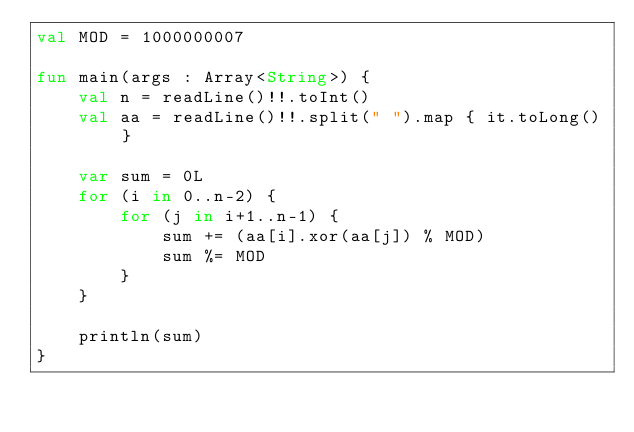Convert code to text. <code><loc_0><loc_0><loc_500><loc_500><_Kotlin_>val MOD = 1000000007

fun main(args : Array<String>) {
    val n = readLine()!!.toInt()
    val aa = readLine()!!.split(" ").map { it.toLong() }

    var sum = 0L
    for (i in 0..n-2) {
        for (j in i+1..n-1) {
            sum += (aa[i].xor(aa[j]) % MOD)
            sum %= MOD
        }
    }

    println(sum)
}</code> 